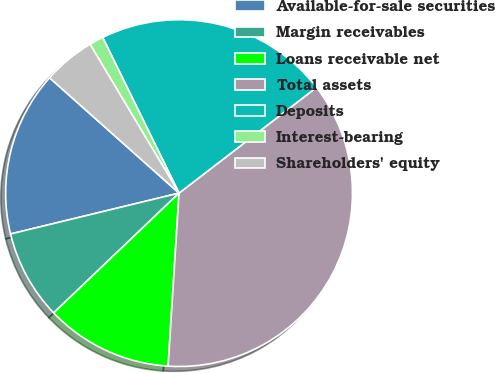Convert chart to OTSL. <chart><loc_0><loc_0><loc_500><loc_500><pie_chart><fcel>Available-for-sale securities<fcel>Margin receivables<fcel>Loans receivable net<fcel>Total assets<fcel>Deposits<fcel>Interest-bearing<fcel>Shareholders' equity<nl><fcel>15.37%<fcel>8.35%<fcel>11.86%<fcel>36.44%<fcel>21.83%<fcel>1.32%<fcel>4.84%<nl></chart> 